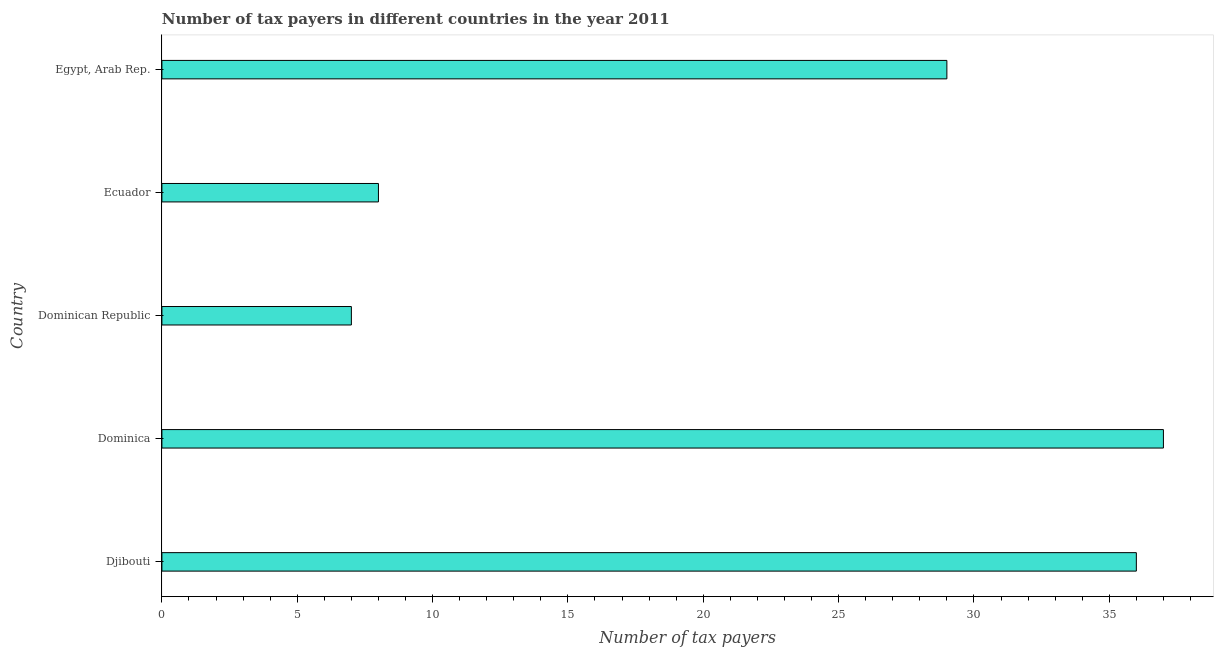Does the graph contain grids?
Give a very brief answer. No. What is the title of the graph?
Offer a very short reply. Number of tax payers in different countries in the year 2011. What is the label or title of the X-axis?
Provide a short and direct response. Number of tax payers. What is the label or title of the Y-axis?
Ensure brevity in your answer.  Country. What is the number of tax payers in Dominica?
Your answer should be very brief. 37. Across all countries, what is the maximum number of tax payers?
Give a very brief answer. 37. In which country was the number of tax payers maximum?
Provide a short and direct response. Dominica. In which country was the number of tax payers minimum?
Your response must be concise. Dominican Republic. What is the sum of the number of tax payers?
Provide a succinct answer. 117. What is the average number of tax payers per country?
Your answer should be compact. 23.4. What is the ratio of the number of tax payers in Ecuador to that in Egypt, Arab Rep.?
Your answer should be very brief. 0.28. Is the number of tax payers in Dominica less than that in Egypt, Arab Rep.?
Offer a terse response. No. Is the difference between the number of tax payers in Djibouti and Dominica greater than the difference between any two countries?
Your response must be concise. No. In how many countries, is the number of tax payers greater than the average number of tax payers taken over all countries?
Offer a very short reply. 3. What is the difference between two consecutive major ticks on the X-axis?
Make the answer very short. 5. What is the Number of tax payers in Dominican Republic?
Your response must be concise. 7. What is the Number of tax payers of Ecuador?
Offer a terse response. 8. What is the Number of tax payers in Egypt, Arab Rep.?
Offer a very short reply. 29. What is the difference between the Number of tax payers in Djibouti and Dominican Republic?
Provide a short and direct response. 29. What is the difference between the Number of tax payers in Djibouti and Ecuador?
Provide a succinct answer. 28. What is the difference between the Number of tax payers in Dominica and Dominican Republic?
Offer a terse response. 30. What is the difference between the Number of tax payers in Dominica and Egypt, Arab Rep.?
Provide a succinct answer. 8. What is the difference between the Number of tax payers in Ecuador and Egypt, Arab Rep.?
Your answer should be compact. -21. What is the ratio of the Number of tax payers in Djibouti to that in Dominica?
Your answer should be compact. 0.97. What is the ratio of the Number of tax payers in Djibouti to that in Dominican Republic?
Give a very brief answer. 5.14. What is the ratio of the Number of tax payers in Djibouti to that in Ecuador?
Provide a short and direct response. 4.5. What is the ratio of the Number of tax payers in Djibouti to that in Egypt, Arab Rep.?
Your answer should be compact. 1.24. What is the ratio of the Number of tax payers in Dominica to that in Dominican Republic?
Your answer should be very brief. 5.29. What is the ratio of the Number of tax payers in Dominica to that in Ecuador?
Your answer should be very brief. 4.62. What is the ratio of the Number of tax payers in Dominica to that in Egypt, Arab Rep.?
Your answer should be very brief. 1.28. What is the ratio of the Number of tax payers in Dominican Republic to that in Ecuador?
Your answer should be very brief. 0.88. What is the ratio of the Number of tax payers in Dominican Republic to that in Egypt, Arab Rep.?
Ensure brevity in your answer.  0.24. What is the ratio of the Number of tax payers in Ecuador to that in Egypt, Arab Rep.?
Make the answer very short. 0.28. 